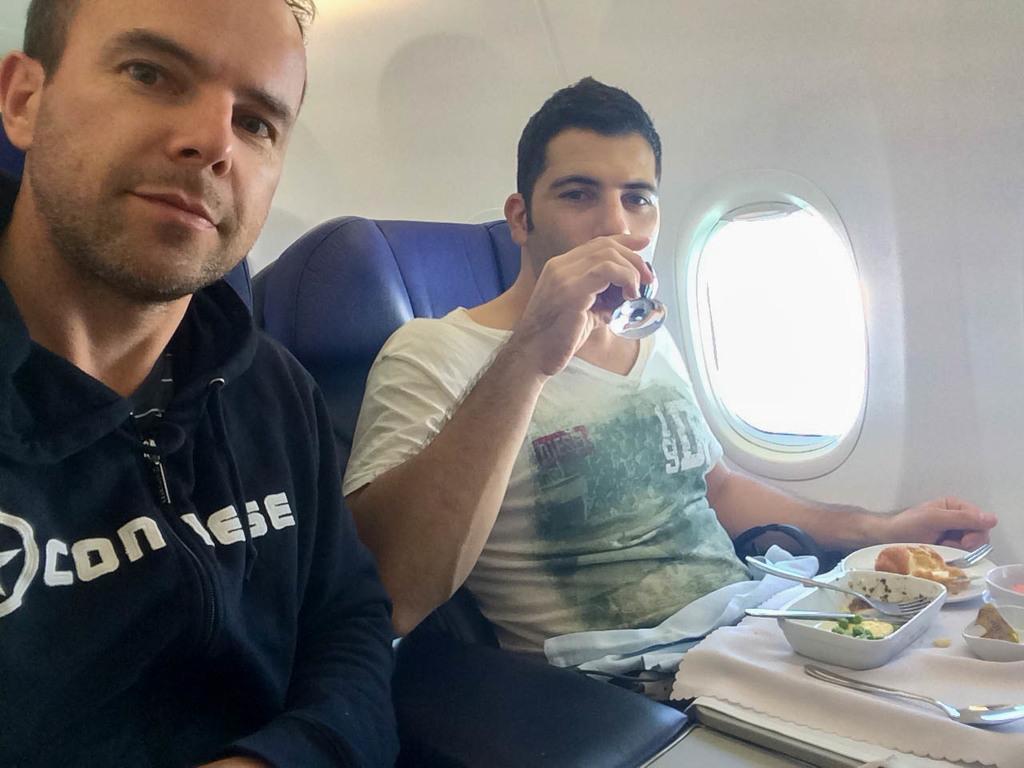How would you summarize this image in a sentence or two? On the left side, there is a person sitting. Beside this person, there is another person sitting on a violet color seat, holding a glass and drinking in front of the table, on which there are food items arranged. Beside him, there is a window. And the background is white in color. 